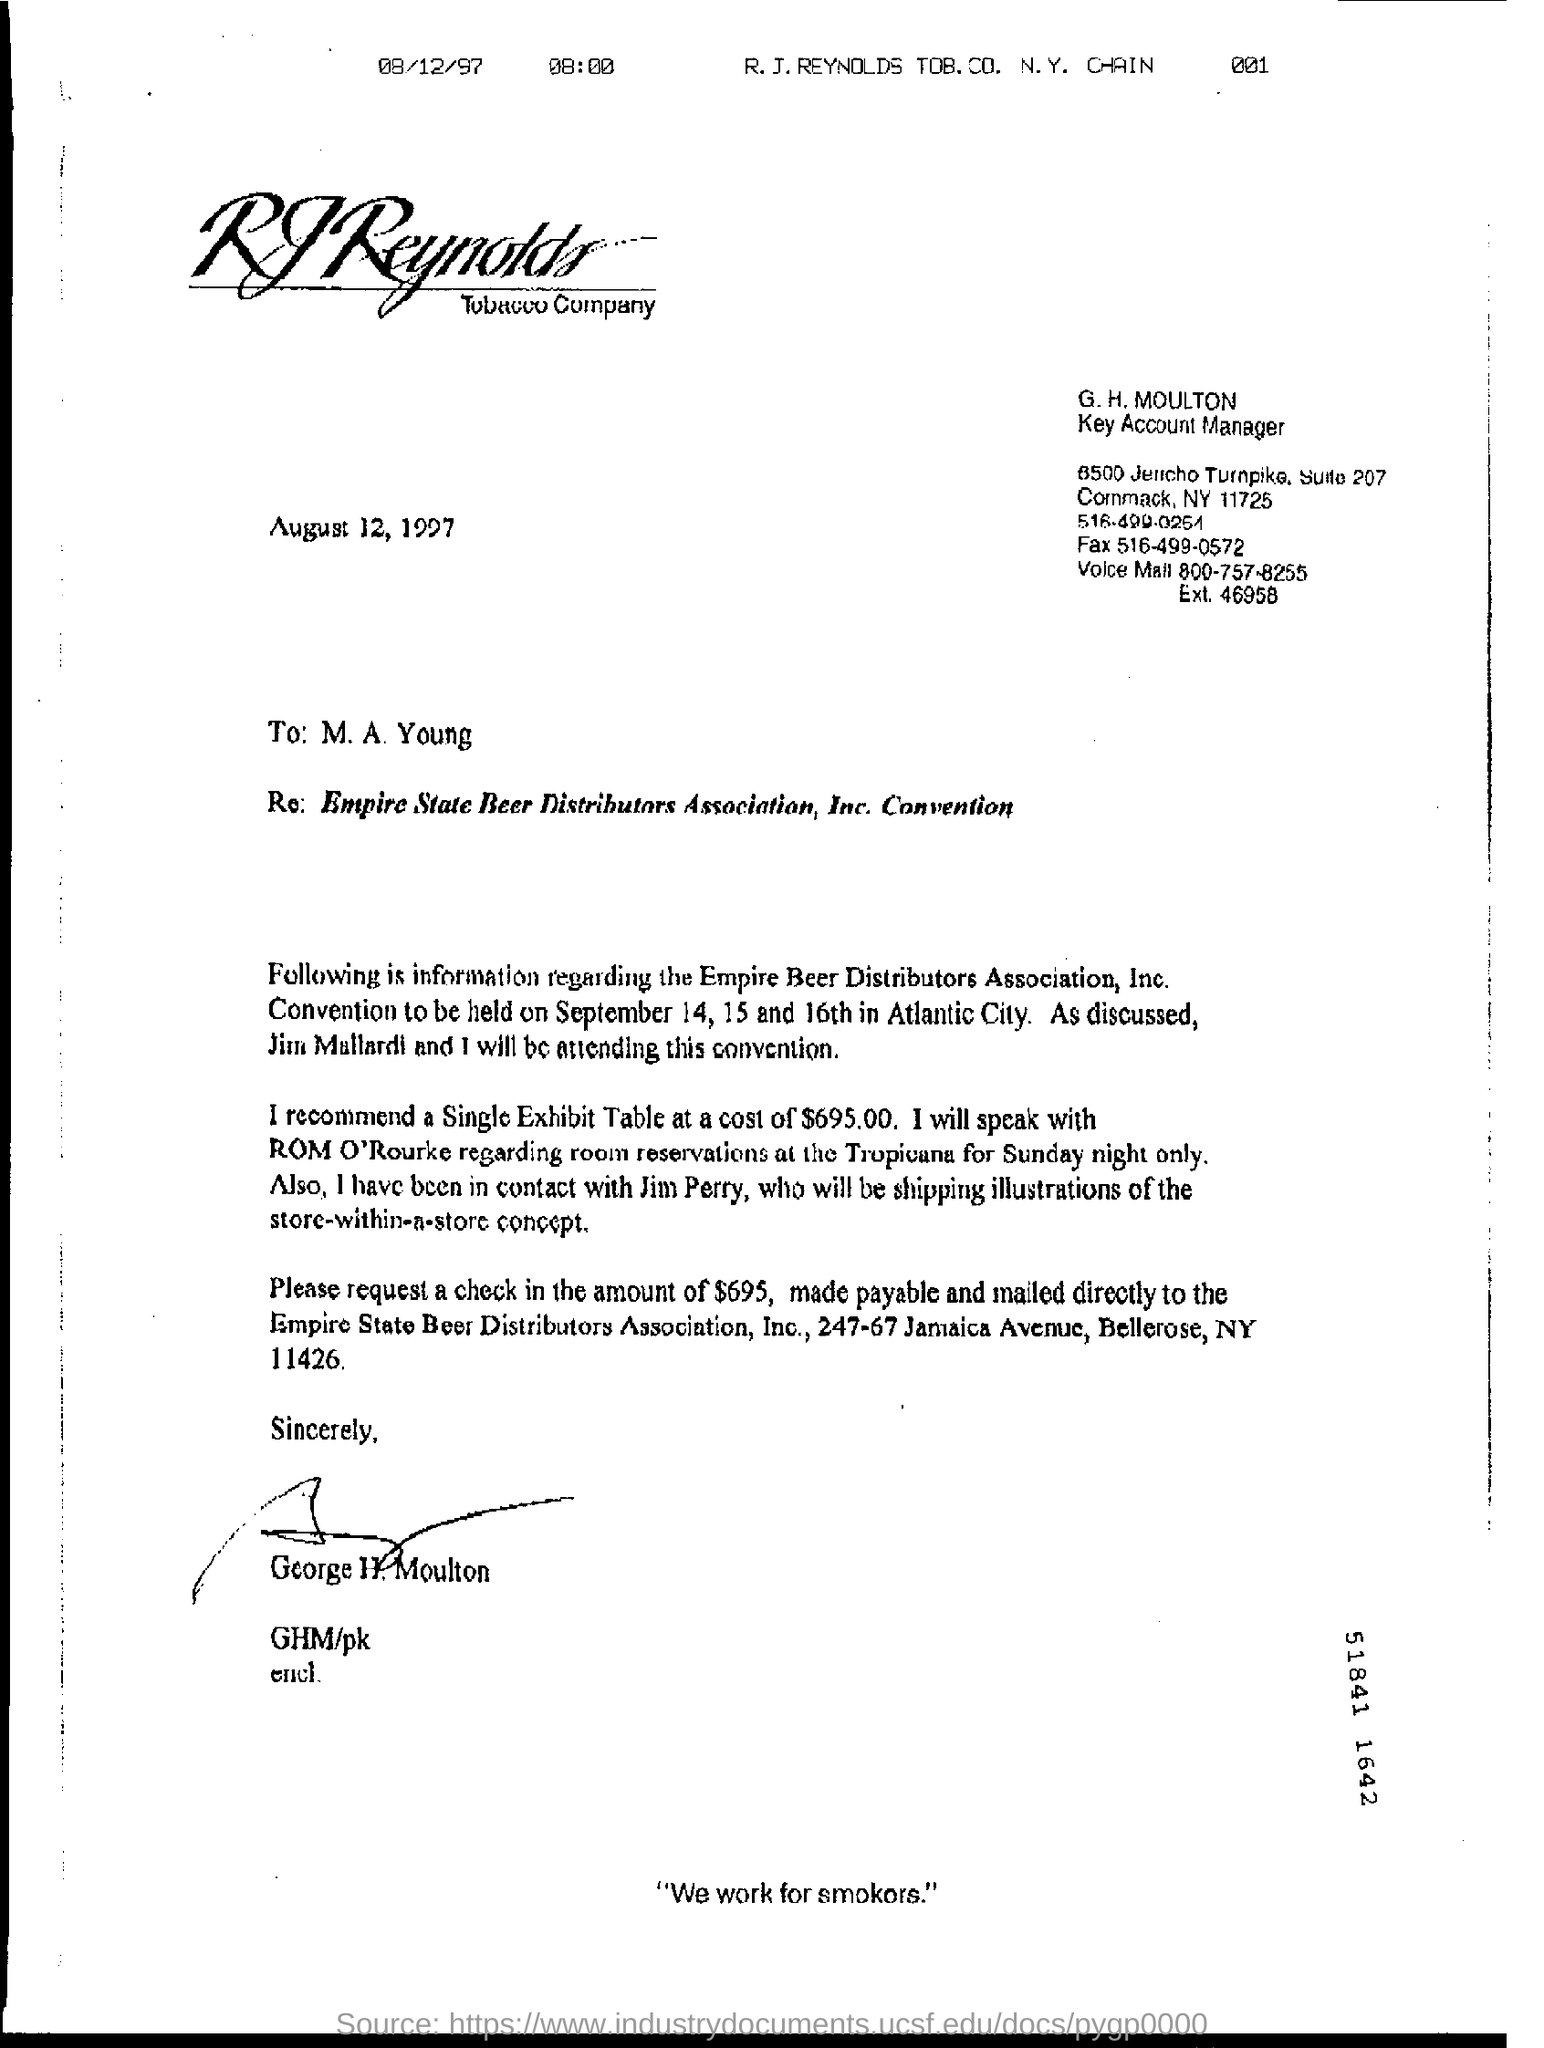Identify some key points in this picture. The cost of a single exhibit table is $695.00. The Empire Beer Distributors Association, Inc. Convention will be held on September 14, 15, and 16th. G.H. Moulton's job title is a Key Account Manager. The location of the Convention will be in Atlantic City. 